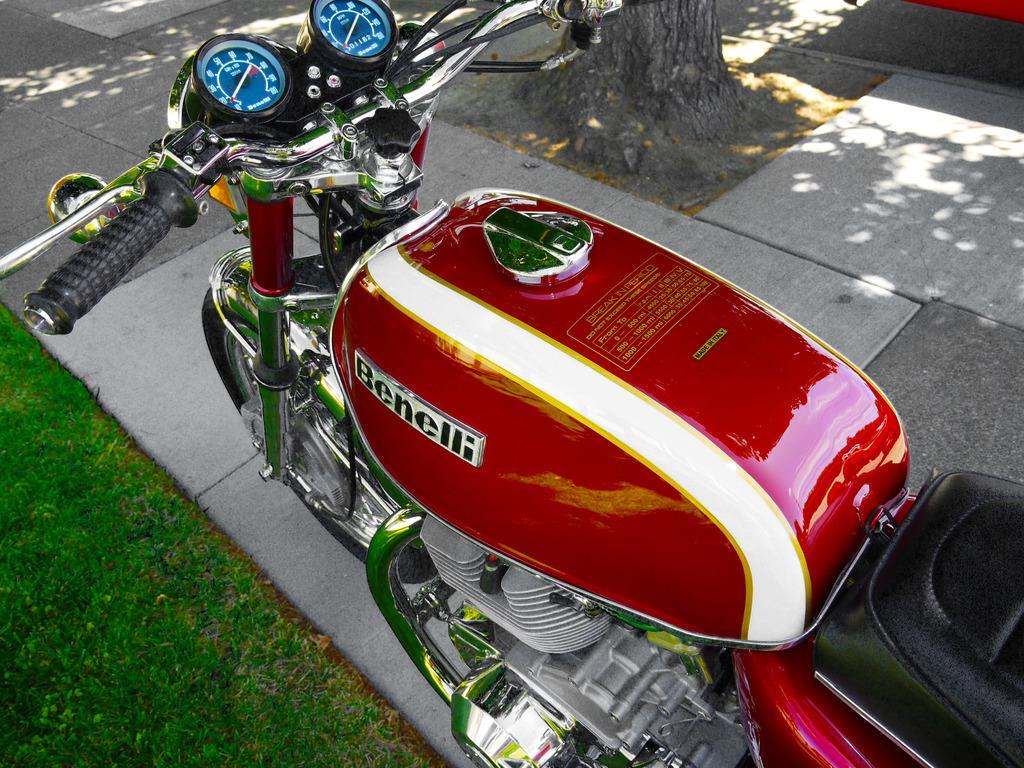Could you give a brief overview of what you see in this image? we can see a bike on a footpath and on the left at the bottom corner there's grass on the ground. At the top we can see a truncated tree and an object on the road. 